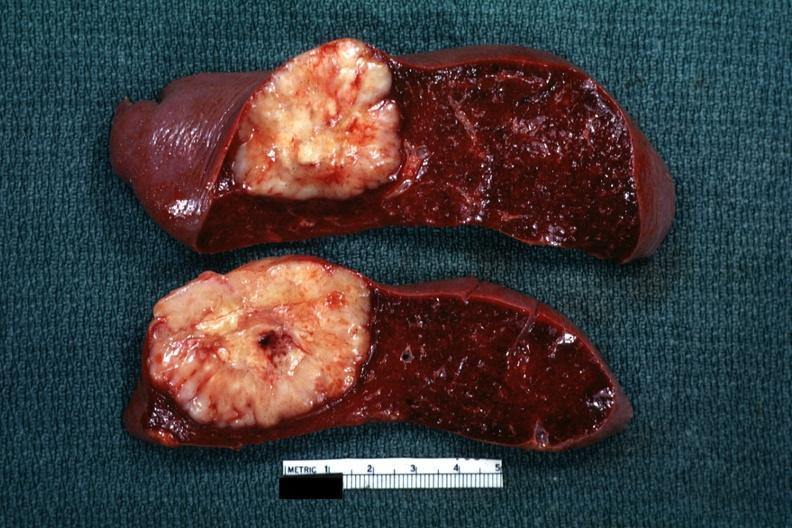s metastatic lung carcinoma present?
Answer the question using a single word or phrase. No 